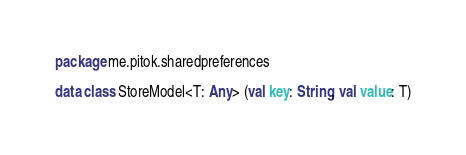Convert code to text. <code><loc_0><loc_0><loc_500><loc_500><_Kotlin_>package me.pitok.sharedpreferences

data class StoreModel<T: Any> (val key: String, val value: T)</code> 